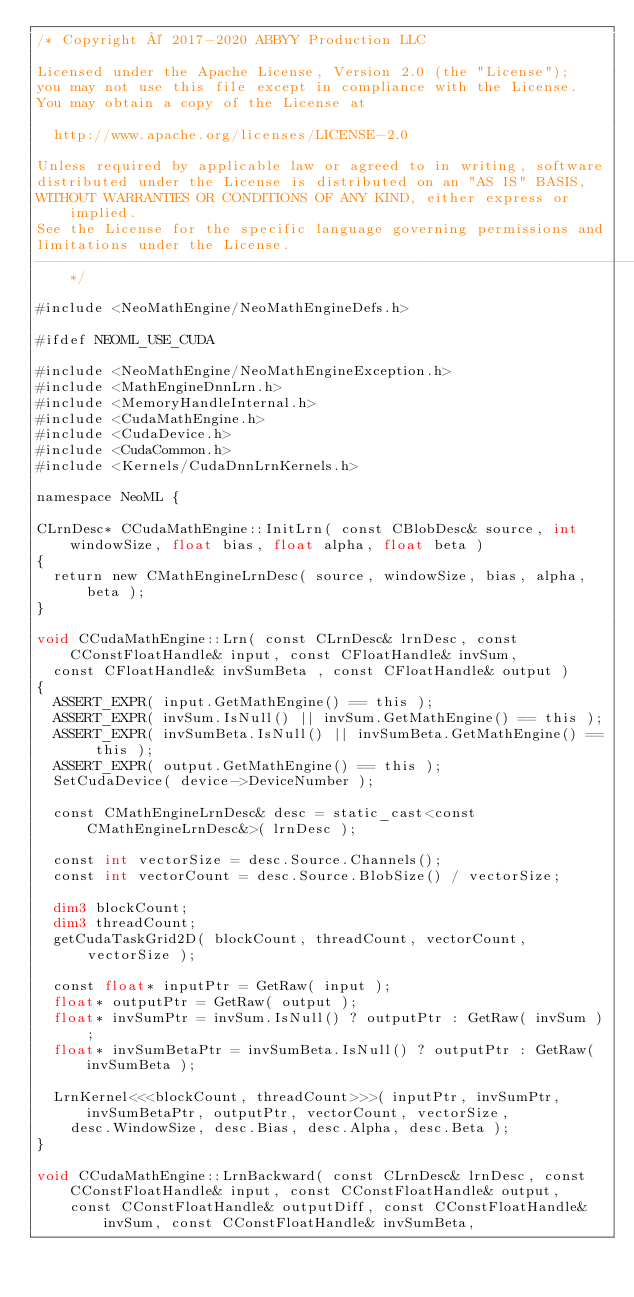<code> <loc_0><loc_0><loc_500><loc_500><_Cuda_>/* Copyright © 2017-2020 ABBYY Production LLC

Licensed under the Apache License, Version 2.0 (the "License");
you may not use this file except in compliance with the License.
You may obtain a copy of the License at

	http://www.apache.org/licenses/LICENSE-2.0

Unless required by applicable law or agreed to in writing, software
distributed under the License is distributed on an "AS IS" BASIS,
WITHOUT WARRANTIES OR CONDITIONS OF ANY KIND, either express or implied.
See the License for the specific language governing permissions and
limitations under the License.
--------------------------------------------------------------------------------------------------------------*/

#include <NeoMathEngine/NeoMathEngineDefs.h>

#ifdef NEOML_USE_CUDA

#include <NeoMathEngine/NeoMathEngineException.h>
#include <MathEngineDnnLrn.h>
#include <MemoryHandleInternal.h>
#include <CudaMathEngine.h>
#include <CudaDevice.h>
#include <CudaCommon.h>
#include <Kernels/CudaDnnLrnKernels.h>

namespace NeoML {

CLrnDesc* CCudaMathEngine::InitLrn( const CBlobDesc& source, int windowSize, float bias, float alpha, float beta )
{
	return new CMathEngineLrnDesc( source, windowSize, bias, alpha, beta );
}

void CCudaMathEngine::Lrn( const CLrnDesc& lrnDesc, const CConstFloatHandle& input, const CFloatHandle& invSum,
	const CFloatHandle& invSumBeta , const CFloatHandle& output )
{
	ASSERT_EXPR( input.GetMathEngine() == this );
	ASSERT_EXPR( invSum.IsNull() || invSum.GetMathEngine() == this );
	ASSERT_EXPR( invSumBeta.IsNull() || invSumBeta.GetMathEngine() == this );
	ASSERT_EXPR( output.GetMathEngine() == this );
	SetCudaDevice( device->DeviceNumber );

	const CMathEngineLrnDesc& desc = static_cast<const CMathEngineLrnDesc&>( lrnDesc );

	const int vectorSize = desc.Source.Channels();
	const int vectorCount = desc.Source.BlobSize() / vectorSize;

	dim3 blockCount;
	dim3 threadCount;
	getCudaTaskGrid2D( blockCount, threadCount, vectorCount, vectorSize );

	const float* inputPtr = GetRaw( input );
	float* outputPtr = GetRaw( output );
	float* invSumPtr = invSum.IsNull() ? outputPtr : GetRaw( invSum );
	float* invSumBetaPtr = invSumBeta.IsNull() ? outputPtr : GetRaw( invSumBeta );

	LrnKernel<<<blockCount, threadCount>>>( inputPtr, invSumPtr, invSumBetaPtr, outputPtr, vectorCount, vectorSize,
		desc.WindowSize, desc.Bias, desc.Alpha, desc.Beta ); 
}

void CCudaMathEngine::LrnBackward( const CLrnDesc& lrnDesc, const CConstFloatHandle& input, const CConstFloatHandle& output,
		const CConstFloatHandle& outputDiff, const CConstFloatHandle& invSum, const CConstFloatHandle& invSumBeta,</code> 